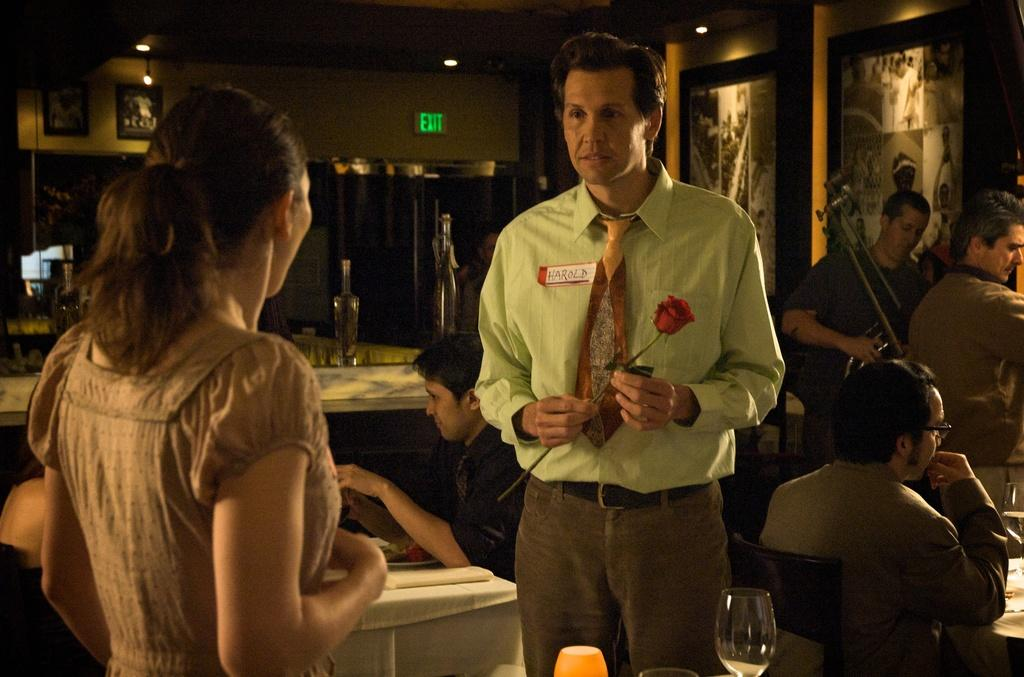What are the people in the image doing? Some people are standing, and some people are sitting. Can you describe the objects on the wall in the image? There are glasses and frames on the wall. What type of oatmeal can be seen in the image? There is no oatmeal present in the image. How many bags are visible in the image? There are no bags visible in the image. 